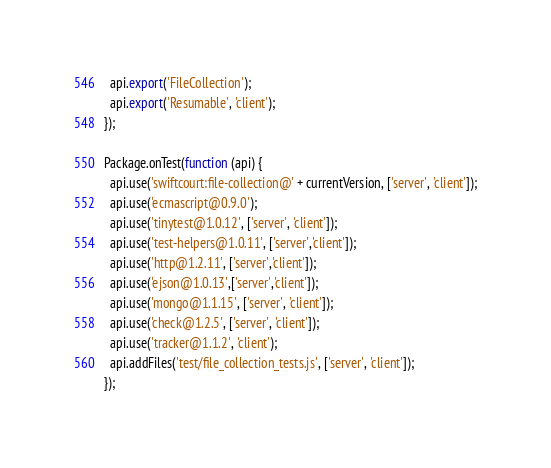<code> <loc_0><loc_0><loc_500><loc_500><_JavaScript_>  api.export('FileCollection');
  api.export('Resumable', 'client');
});

Package.onTest(function (api) {
  api.use('swiftcourt:file-collection@' + currentVersion, ['server', 'client']);
  api.use('ecmascript@0.9.0');
  api.use('tinytest@1.0.12', ['server', 'client']);
  api.use('test-helpers@1.0.11', ['server','client']);
  api.use('http@1.2.11', ['server','client']);
  api.use('ejson@1.0.13',['server','client']);
  api.use('mongo@1.1.15', ['server', 'client']);
  api.use('check@1.2.5', ['server', 'client']);
  api.use('tracker@1.1.2', 'client');
  api.addFiles('test/file_collection_tests.js', ['server', 'client']);
});
</code> 